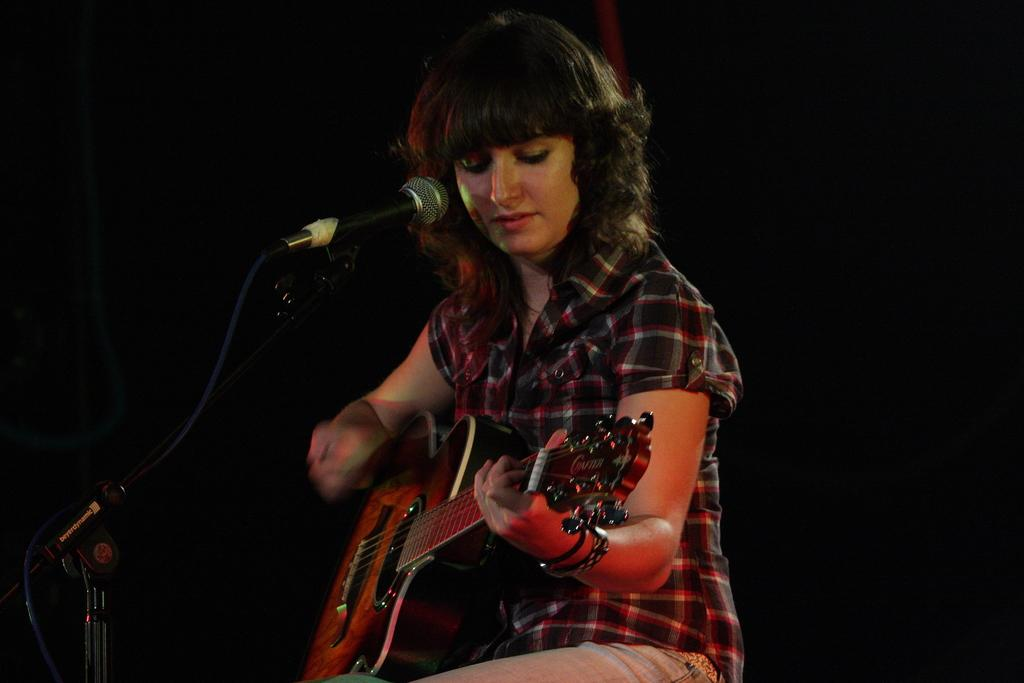Who is the main subject in the image? There is a woman in the image. What is the woman doing in the image? The woman is sitting and playing the guitar. What object is in front of the woman? There is a microphone in front of the woman. What type of paste is the woman using to play the guitar in the image? There is no paste present in the image, and the woman is not using any paste to play the guitar. 